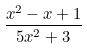<formula> <loc_0><loc_0><loc_500><loc_500>\frac { x ^ { 2 } - x + 1 } { 5 x ^ { 2 } + 3 }</formula> 